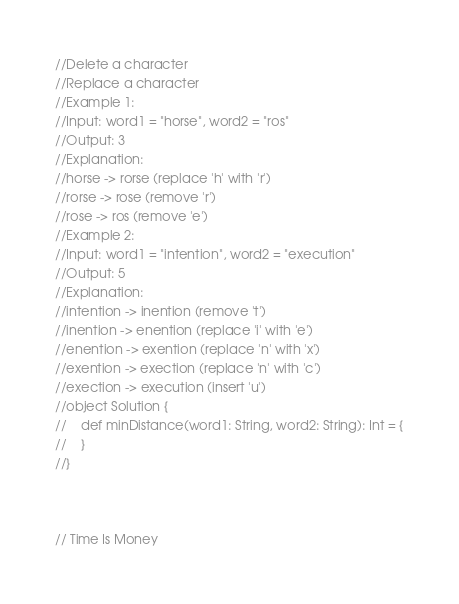Convert code to text. <code><loc_0><loc_0><loc_500><loc_500><_Scala_>//Delete a character
//Replace a character
//Example 1:
//Input: word1 = "horse", word2 = "ros"
//Output: 3
//Explanation: 
//horse -> rorse (replace 'h' with 'r')
//rorse -> rose (remove 'r')
//rose -> ros (remove 'e')
//Example 2:
//Input: word1 = "intention", word2 = "execution"
//Output: 5
//Explanation: 
//intention -> inention (remove 't')
//inention -> enention (replace 'i' with 'e')
//enention -> exention (replace 'n' with 'x')
//exention -> exection (replace 'n' with 'c')
//exection -> execution (insert 'u')
//object Solution {
//    def minDistance(word1: String, word2: String): Int = {
//    }
//}



// Time Is Money</code> 